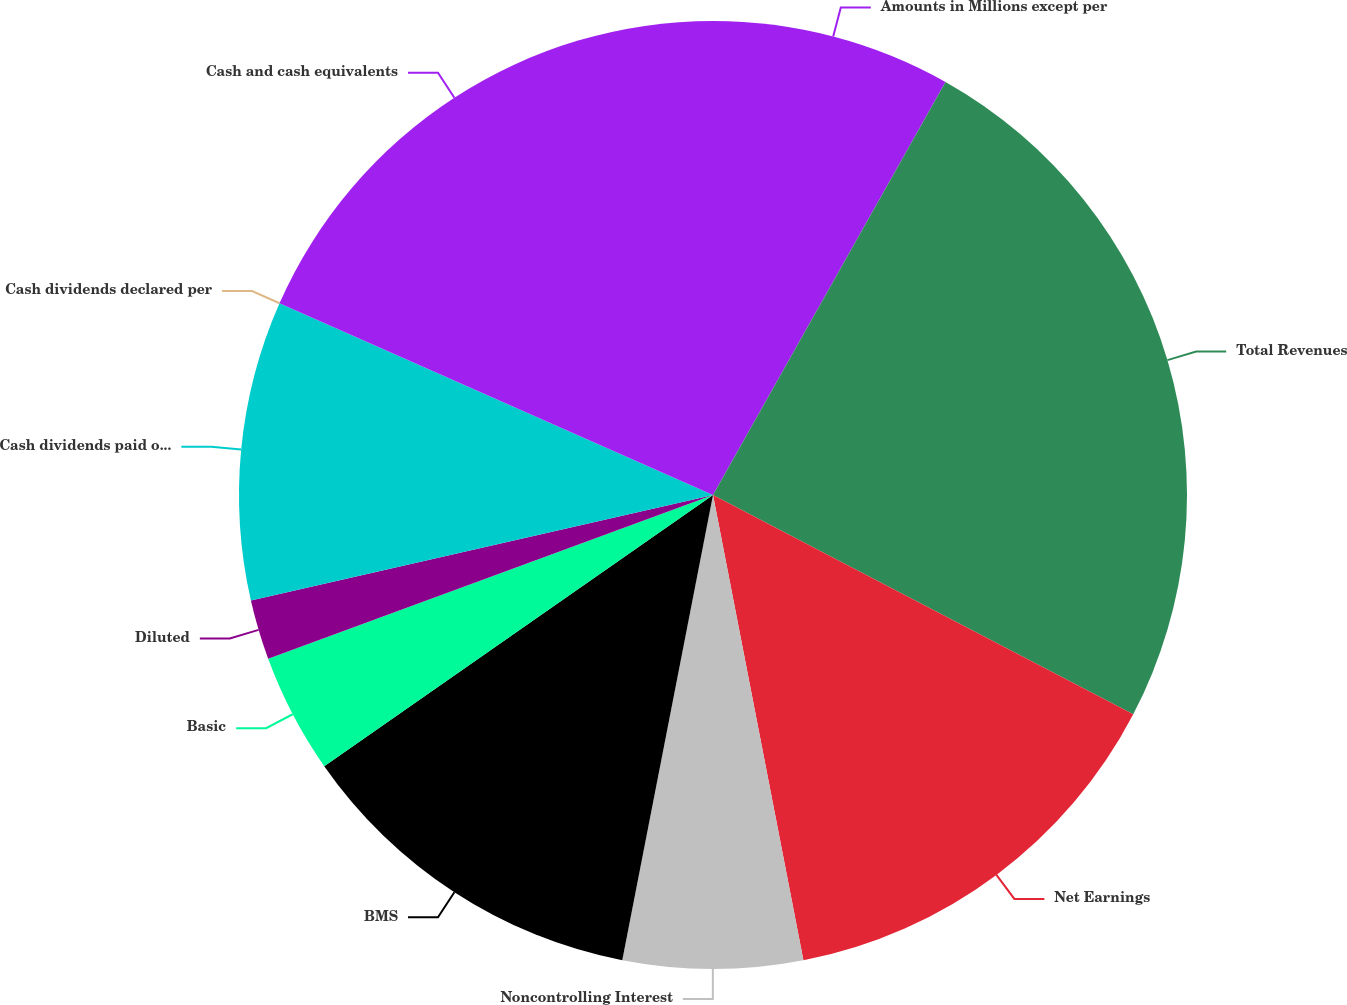Convert chart. <chart><loc_0><loc_0><loc_500><loc_500><pie_chart><fcel>Amounts in Millions except per<fcel>Total Revenues<fcel>Net Earnings<fcel>Noncontrolling Interest<fcel>BMS<fcel>Basic<fcel>Diluted<fcel>Cash dividends paid on BMS<fcel>Cash dividends declared per<fcel>Cash and cash equivalents<nl><fcel>8.16%<fcel>24.49%<fcel>14.29%<fcel>6.12%<fcel>12.24%<fcel>4.08%<fcel>2.04%<fcel>10.2%<fcel>0.0%<fcel>18.37%<nl></chart> 